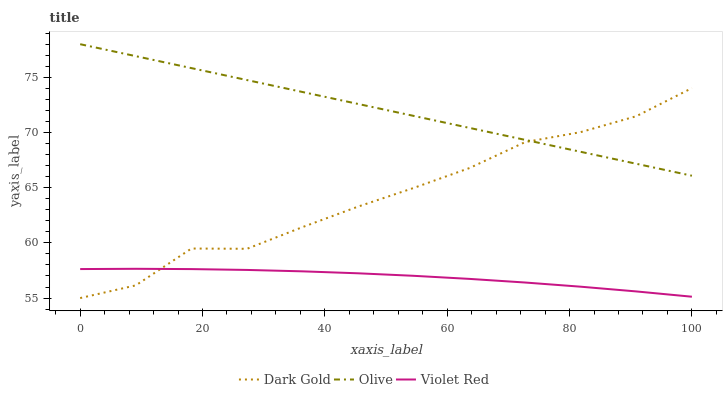Does Violet Red have the minimum area under the curve?
Answer yes or no. Yes. Does Olive have the maximum area under the curve?
Answer yes or no. Yes. Does Dark Gold have the minimum area under the curve?
Answer yes or no. No. Does Dark Gold have the maximum area under the curve?
Answer yes or no. No. Is Olive the smoothest?
Answer yes or no. Yes. Is Dark Gold the roughest?
Answer yes or no. Yes. Is Violet Red the smoothest?
Answer yes or no. No. Is Violet Red the roughest?
Answer yes or no. No. Does Dark Gold have the lowest value?
Answer yes or no. Yes. Does Violet Red have the lowest value?
Answer yes or no. No. Does Olive have the highest value?
Answer yes or no. Yes. Does Dark Gold have the highest value?
Answer yes or no. No. Is Violet Red less than Olive?
Answer yes or no. Yes. Is Olive greater than Violet Red?
Answer yes or no. Yes. Does Violet Red intersect Dark Gold?
Answer yes or no. Yes. Is Violet Red less than Dark Gold?
Answer yes or no. No. Is Violet Red greater than Dark Gold?
Answer yes or no. No. Does Violet Red intersect Olive?
Answer yes or no. No. 